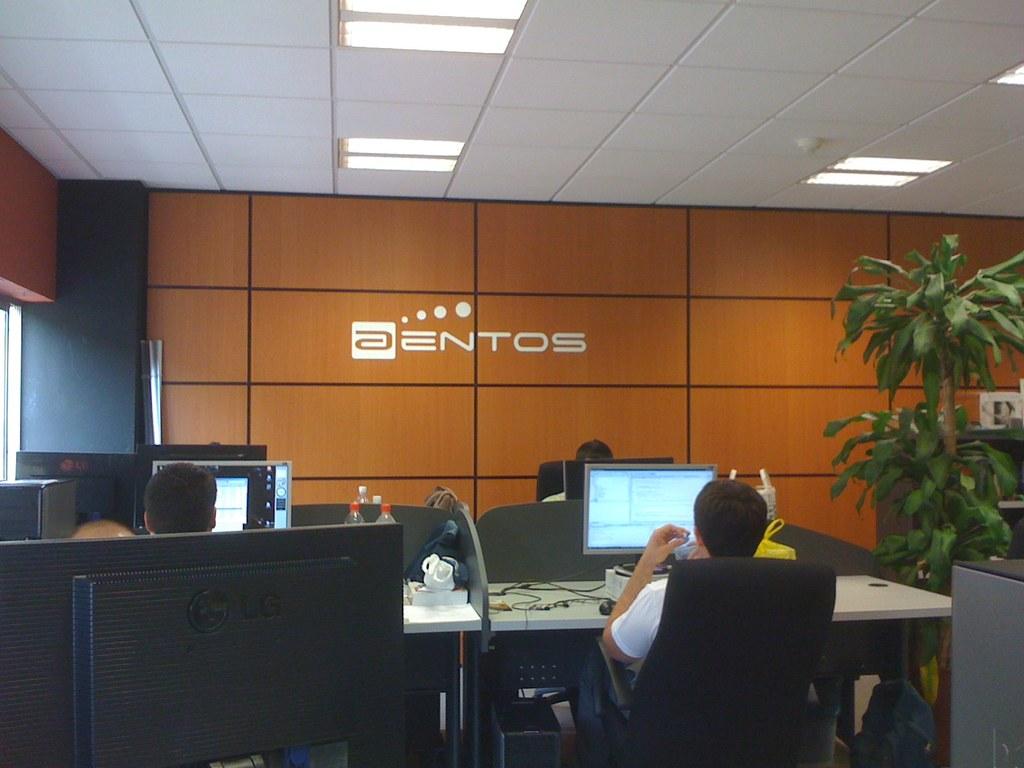What is the name of this company?
Keep it short and to the point. Aentos. 